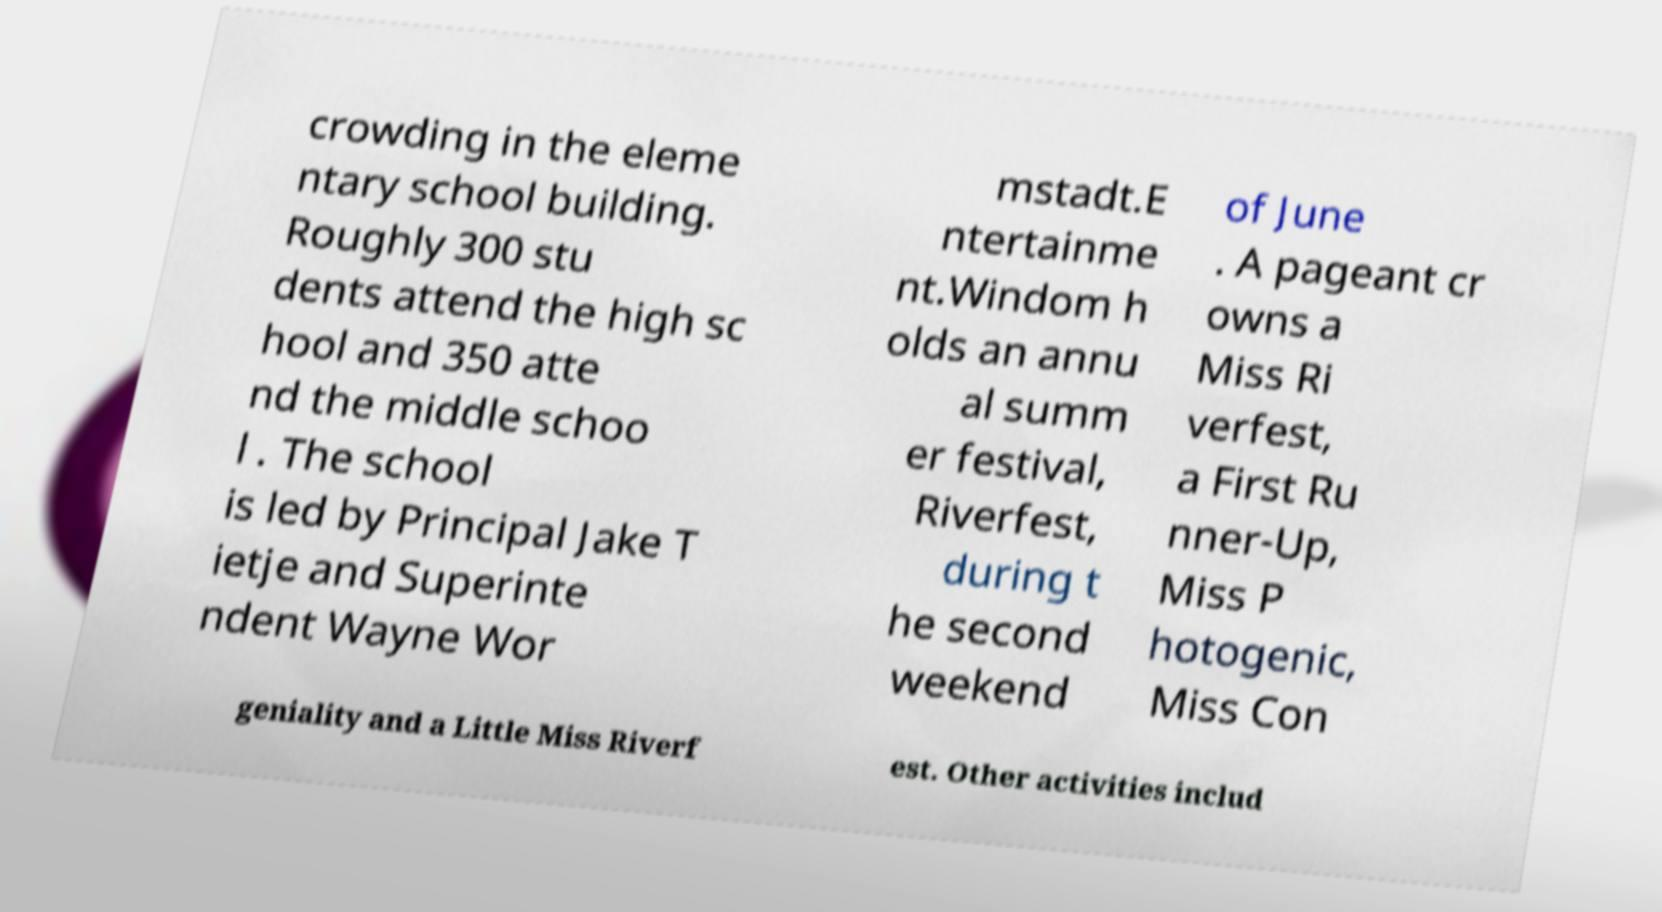Could you extract and type out the text from this image? crowding in the eleme ntary school building. Roughly 300 stu dents attend the high sc hool and 350 atte nd the middle schoo l . The school is led by Principal Jake T ietje and Superinte ndent Wayne Wor mstadt.E ntertainme nt.Windom h olds an annu al summ er festival, Riverfest, during t he second weekend of June . A pageant cr owns a Miss Ri verfest, a First Ru nner-Up, Miss P hotogenic, Miss Con geniality and a Little Miss Riverf est. Other activities includ 